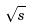Convert formula to latex. <formula><loc_0><loc_0><loc_500><loc_500>\sqrt { s }</formula> 